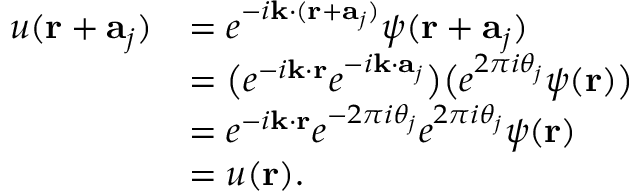Convert formula to latex. <formula><loc_0><loc_0><loc_500><loc_500>{ \begin{array} { r l } { u ( r + a _ { j } ) } & { = e ^ { - i k \cdot ( r + a _ { j } ) } \psi ( r + a _ { j } ) } \\ & { = { \left ( } e ^ { - i k \cdot r } e ^ { - i k \cdot a _ { j } } { \right ) } { \left ( } e ^ { 2 \pi i \theta _ { j } } \psi ( r ) { \right ) } } \\ & { = e ^ { - i k \cdot r } e ^ { - 2 \pi i \theta _ { j } } e ^ { 2 \pi i \theta _ { j } } \psi ( r ) } \\ & { = u ( r ) . } \end{array} }</formula> 